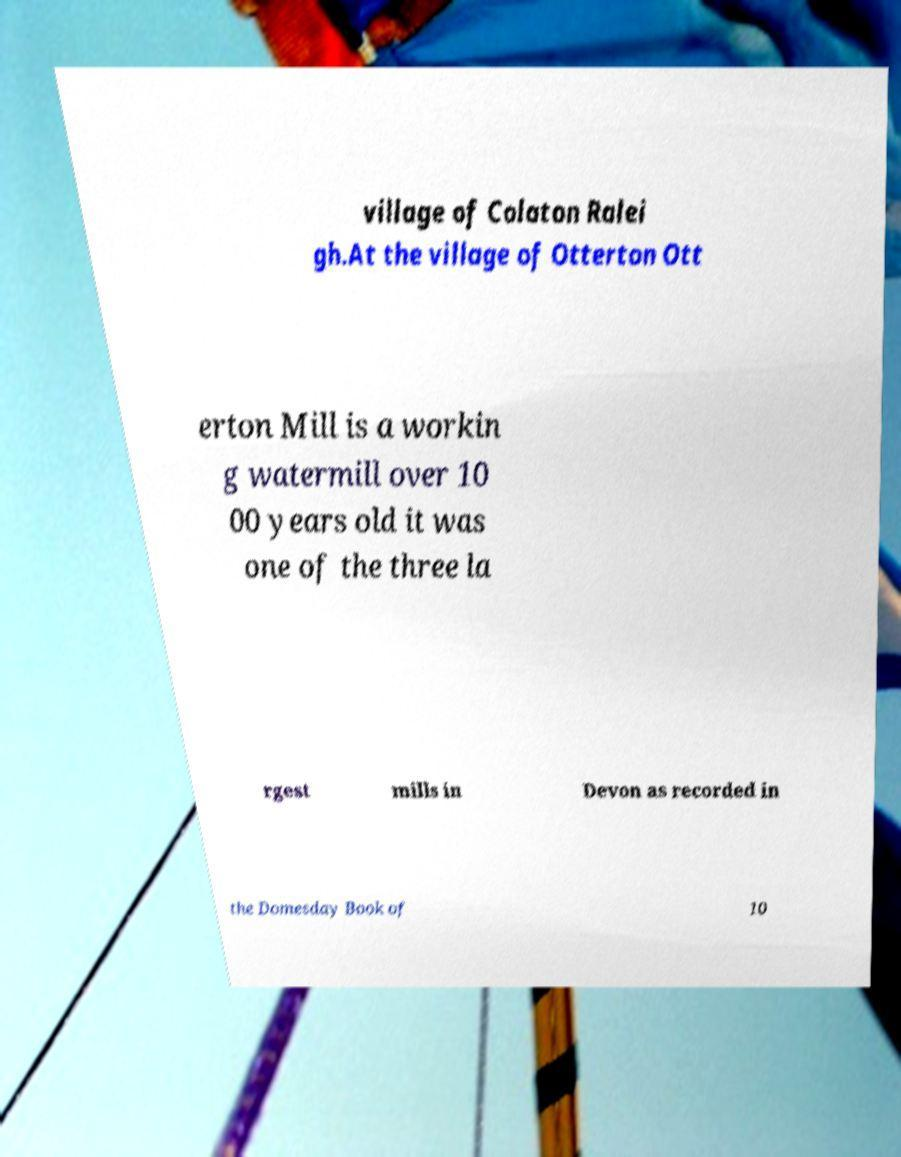Can you read and provide the text displayed in the image?This photo seems to have some interesting text. Can you extract and type it out for me? village of Colaton Ralei gh.At the village of Otterton Ott erton Mill is a workin g watermill over 10 00 years old it was one of the three la rgest mills in Devon as recorded in the Domesday Book of 10 